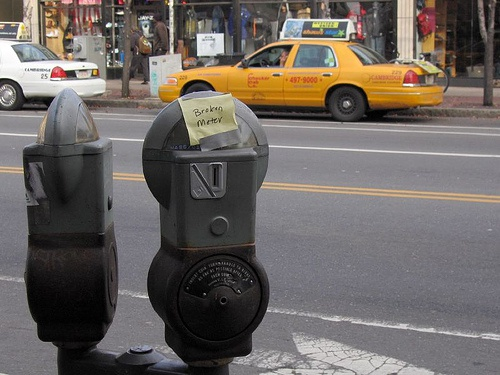Describe the objects in this image and their specific colors. I can see parking meter in gray, black, darkgray, and tan tones, parking meter in gray, black, and darkgray tones, car in gray, orange, black, and olive tones, car in gray, white, darkgray, and black tones, and people in gray, black, and maroon tones in this image. 